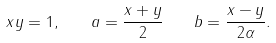Convert formula to latex. <formula><loc_0><loc_0><loc_500><loc_500>x y = 1 , \quad a = { \frac { x + y } { 2 } } \quad b = { \frac { x - y } { 2 \alpha } } .</formula> 